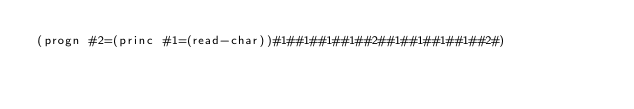<code> <loc_0><loc_0><loc_500><loc_500><_Lisp_>(progn #2=(princ #1=(read-char))#1##1##1##1##2##1##1##1##1##2#)</code> 